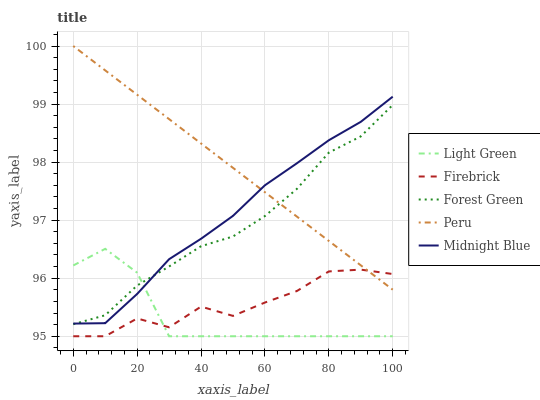Does Light Green have the minimum area under the curve?
Answer yes or no. Yes. Does Peru have the maximum area under the curve?
Answer yes or no. Yes. Does Firebrick have the minimum area under the curve?
Answer yes or no. No. Does Firebrick have the maximum area under the curve?
Answer yes or no. No. Is Peru the smoothest?
Answer yes or no. Yes. Is Firebrick the roughest?
Answer yes or no. Yes. Is Forest Green the smoothest?
Answer yes or no. No. Is Forest Green the roughest?
Answer yes or no. No. Does Firebrick have the lowest value?
Answer yes or no. Yes. Does Forest Green have the lowest value?
Answer yes or no. No. Does Peru have the highest value?
Answer yes or no. Yes. Does Forest Green have the highest value?
Answer yes or no. No. Is Firebrick less than Forest Green?
Answer yes or no. Yes. Is Midnight Blue greater than Firebrick?
Answer yes or no. Yes. Does Forest Green intersect Peru?
Answer yes or no. Yes. Is Forest Green less than Peru?
Answer yes or no. No. Is Forest Green greater than Peru?
Answer yes or no. No. Does Firebrick intersect Forest Green?
Answer yes or no. No. 